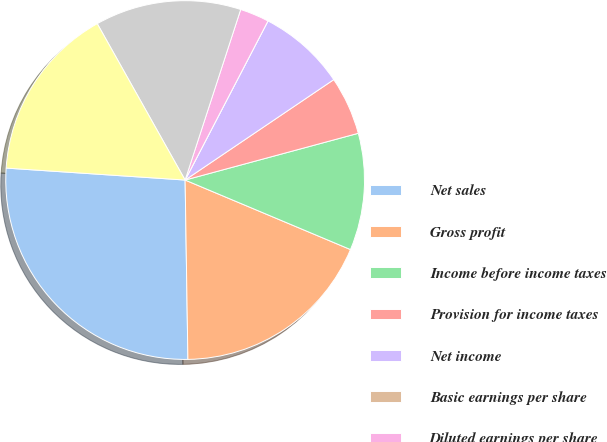Convert chart. <chart><loc_0><loc_0><loc_500><loc_500><pie_chart><fcel>Net sales<fcel>Gross profit<fcel>Income before income taxes<fcel>Provision for income taxes<fcel>Net income<fcel>Basic earnings per share<fcel>Diluted earnings per share<fcel>Shares used in computation of<fcel>Diluted<nl><fcel>26.31%<fcel>18.42%<fcel>10.53%<fcel>5.26%<fcel>7.9%<fcel>0.0%<fcel>2.63%<fcel>13.16%<fcel>15.79%<nl></chart> 